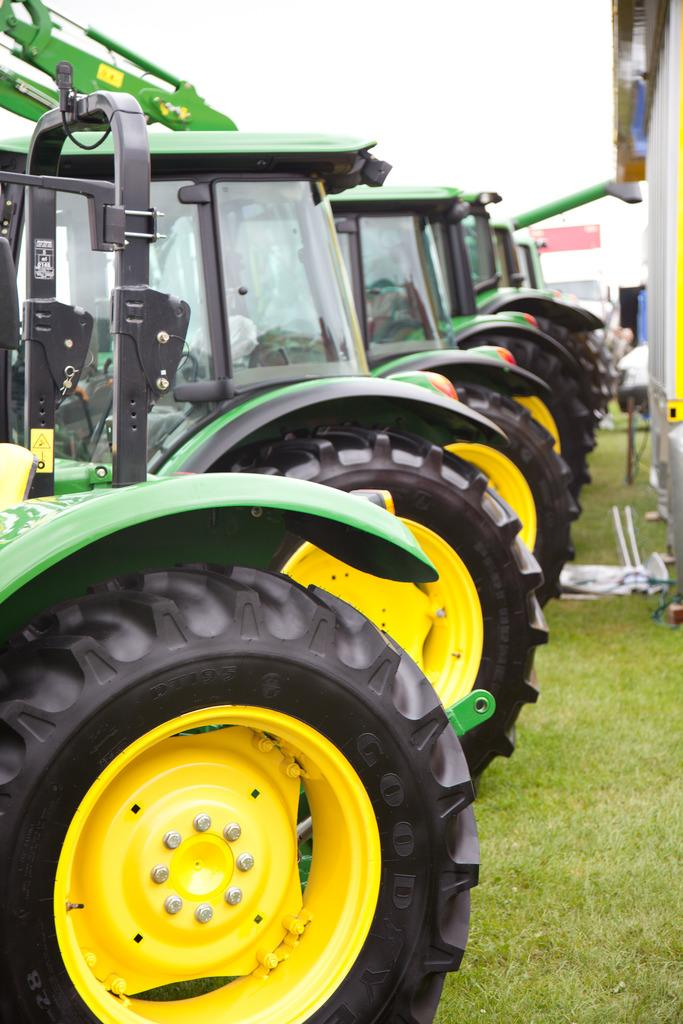What types of vehicles can be seen in the image? There are vehicles in the image, but the specific types cannot be determined from the provided facts. What type of natural environment is visible in the image? There is grass visible in the image, which suggests a natural setting. What other objects can be seen in the image besides the vehicles? There are other objects in the image, but their nature cannot be determined from the provided facts. What is visible in the background of the image? The sky is visible in the background of the image. What is the purpose of the foot in the image? There is no foot present in the image, so it is not possible to determine its purpose. 